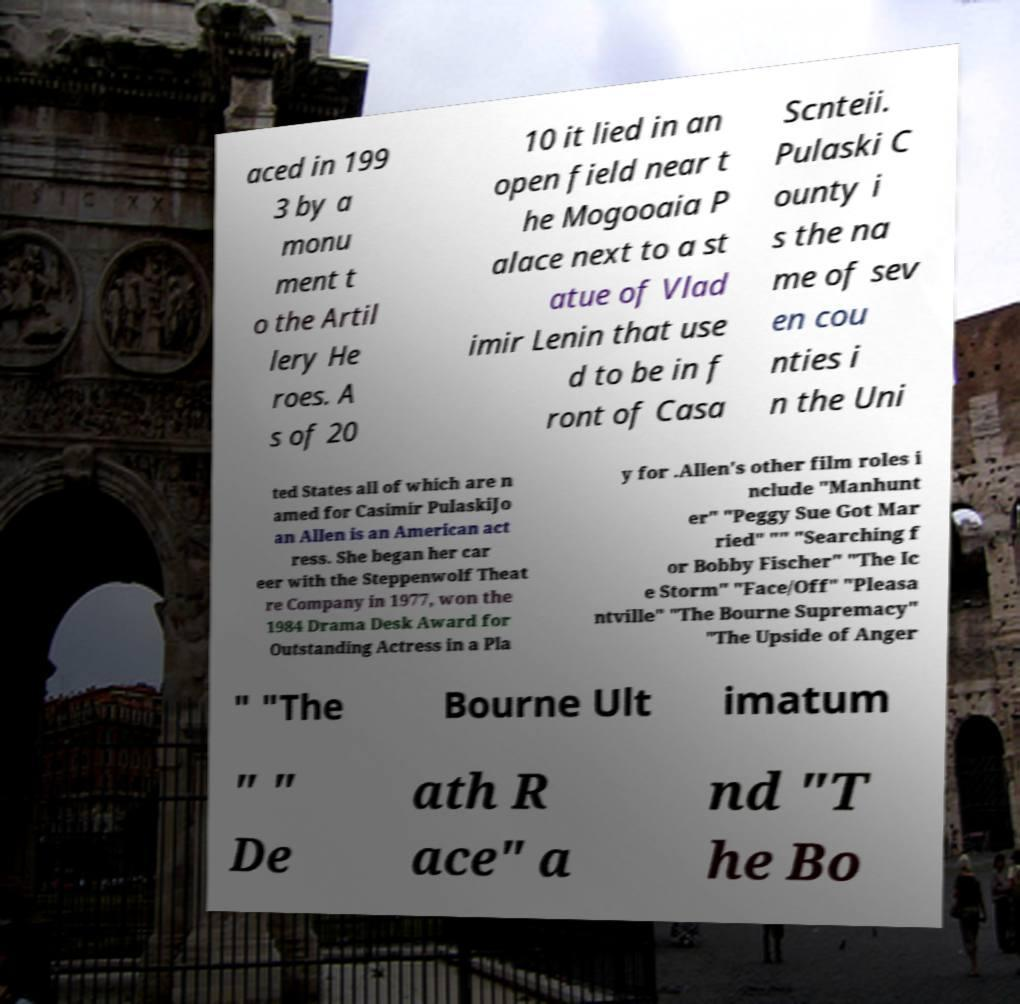Could you extract and type out the text from this image? aced in 199 3 by a monu ment t o the Artil lery He roes. A s of 20 10 it lied in an open field near t he Mogooaia P alace next to a st atue of Vlad imir Lenin that use d to be in f ront of Casa Scnteii. Pulaski C ounty i s the na me of sev en cou nties i n the Uni ted States all of which are n amed for Casimir PulaskiJo an Allen is an American act ress. She began her car eer with the Steppenwolf Theat re Company in 1977, won the 1984 Drama Desk Award for Outstanding Actress in a Pla y for .Allen's other film roles i nclude "Manhunt er" "Peggy Sue Got Mar ried" "" "Searching f or Bobby Fischer" "The Ic e Storm" "Face/Off" "Pleasa ntville" "The Bourne Supremacy" "The Upside of Anger " "The Bourne Ult imatum " " De ath R ace" a nd "T he Bo 